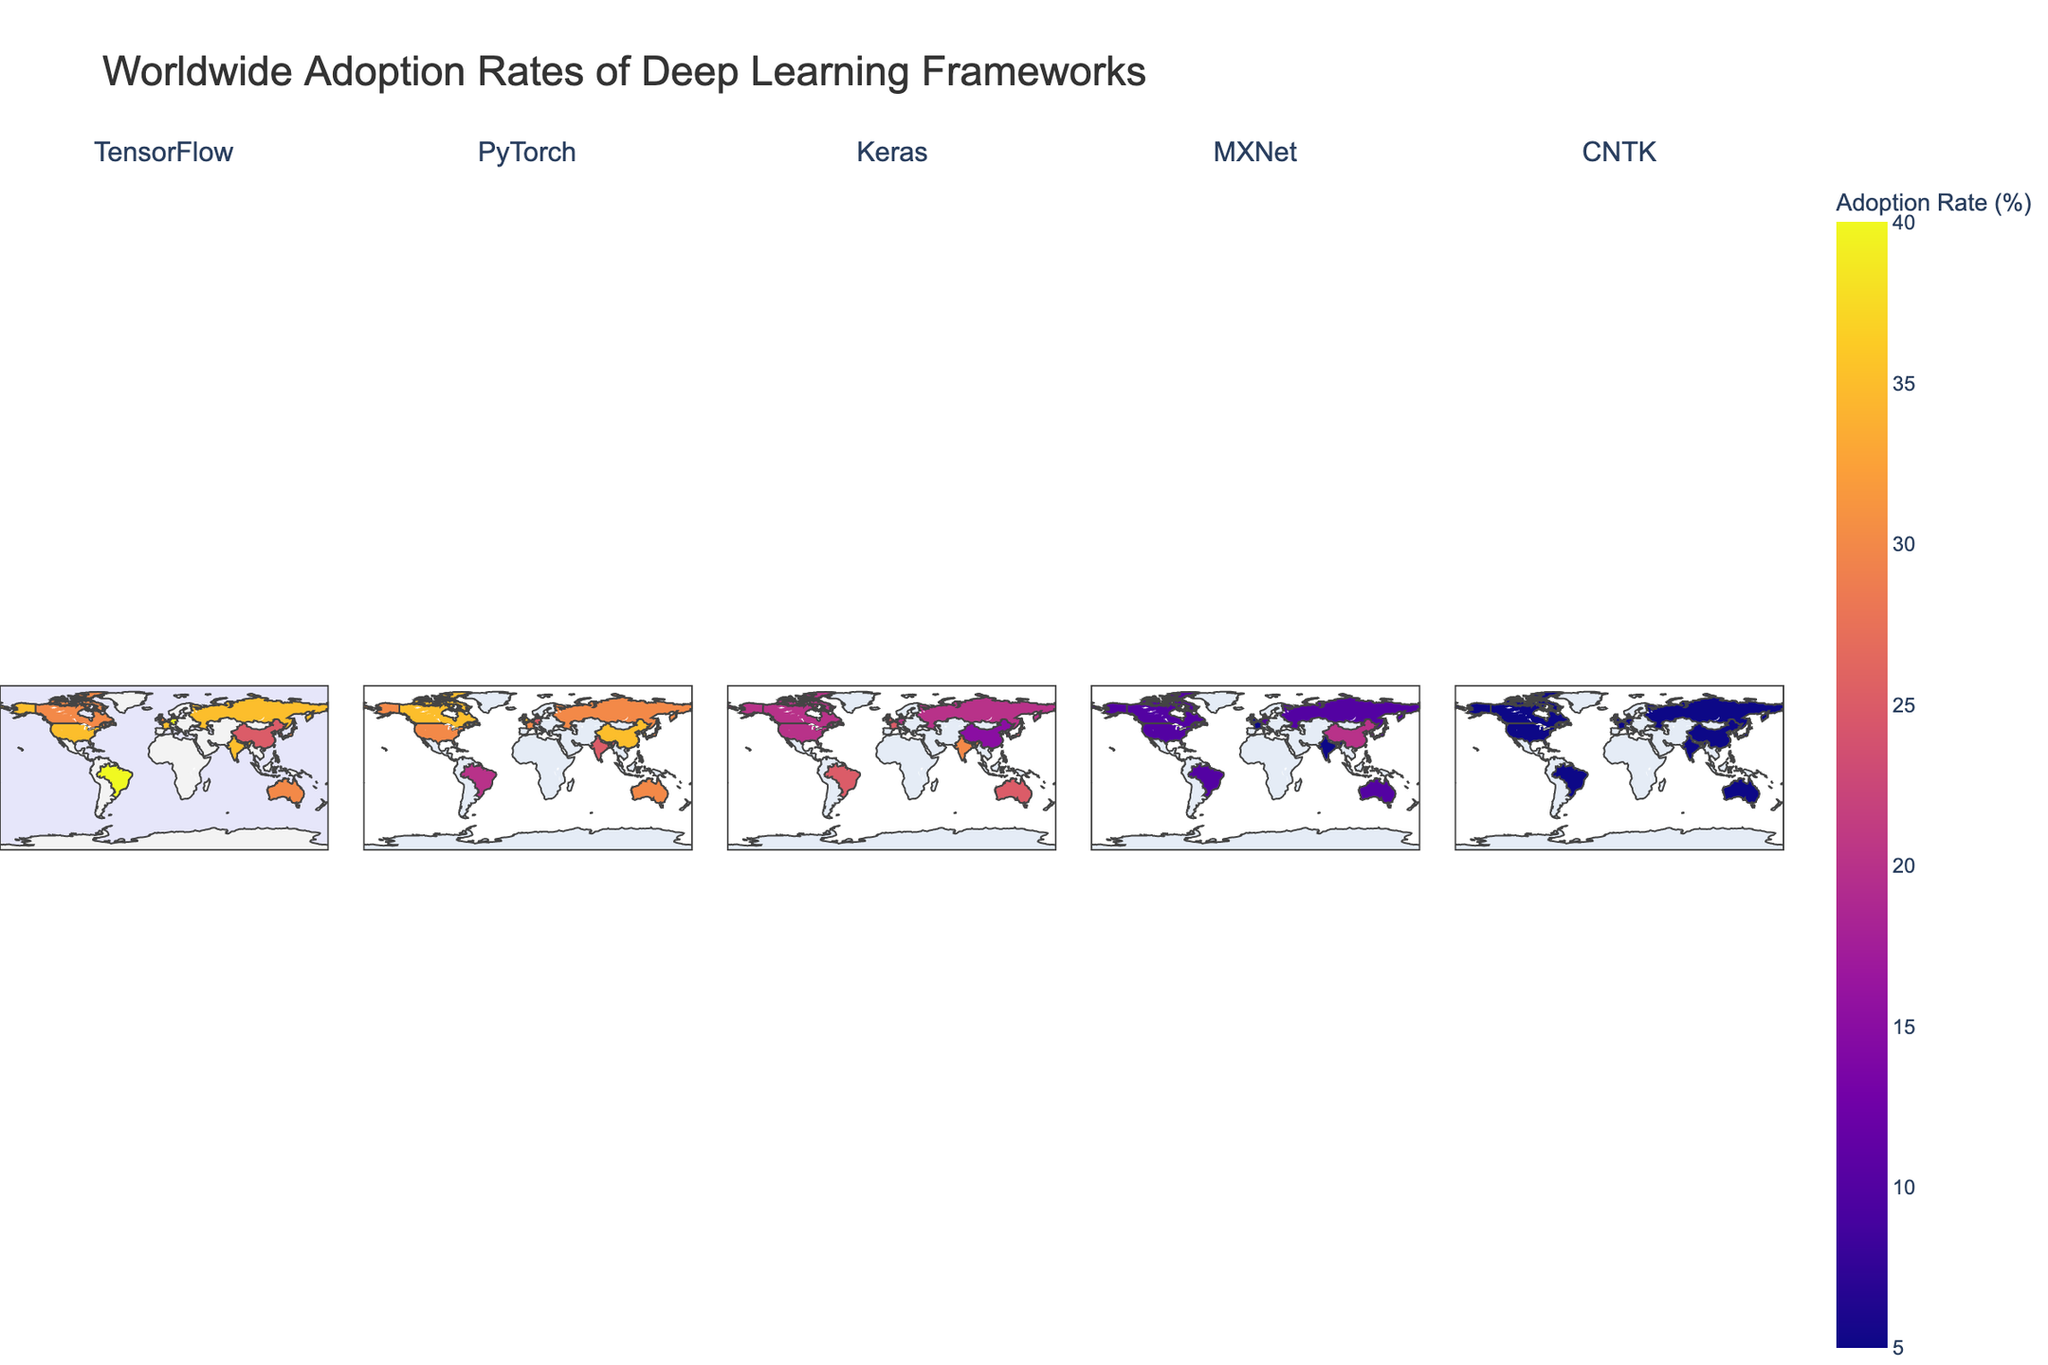What is the title of the figure? The title of the figure is usually found at the top of the plot. It provides a brief description of what the figure is about.
Answer: Worldwide Adoption Rates of Deep Learning Frameworks Which country shows the highest adoption rate for TensorFlow? By observing the color intensity of the regions in the facet corresponding to TensorFlow, we see that Germany has the darkest shade, indicating the highest adoption rate.
Answer: Germany Which deep learning framework has the highest overall adoption rate in Israel? In the facet corresponding to Israel, we observe the darkest shade in the PyTorch section, indicating the highest adoption rate for PyTorch.
Answer: PyTorch How do the adoption rates of MXNet in China and South Korea compare? Look at the facets for MXNet and find the shades for China and South Korea. Both countries have similar deeper shades, suggesting comparable high adoption rates.
Answer: Comparable What is the average adoption rate of Keras across Japan, Australia, and Brazil? Check the Keras facet for the adoption rates in the mentioned countries and sum them up (25+25+25). Then divide by the number of countries (3). The average is (25+25+25)/3 = 25.
Answer: 25 Which two countries have identical adoption rates for CNTK? In the CNTK facet, observe the shades representing adoption rates. Many countries show the same color intensity, which corresponds to the same adoption rate of 5%. For example, United States and China.
Answer: United States and China Considering just Europe, which country shows the highest adoption rate for PyTorch? In the PyTorch facet, looking at European countries, the United Kingdom has the darkest shade, indicating the highest adoption rate for PyTorch.
Answer: United Kingdom What is the difference in adoption rates of TensorFlow between the United States and Canada? Check the TensorFlow adoption data for both countries: United States (35%) and Canada (30%). The difference is 35 - 30 = 5%.
Answer: 5 Which country has the most balanced adoption rates across all five frameworks? A balanced adoption rate would mean showing similar shades across all facets for this country. Looking at the plot, Japan provides such a balance with similar color intensities across all frameworks.
Answer: Japan 